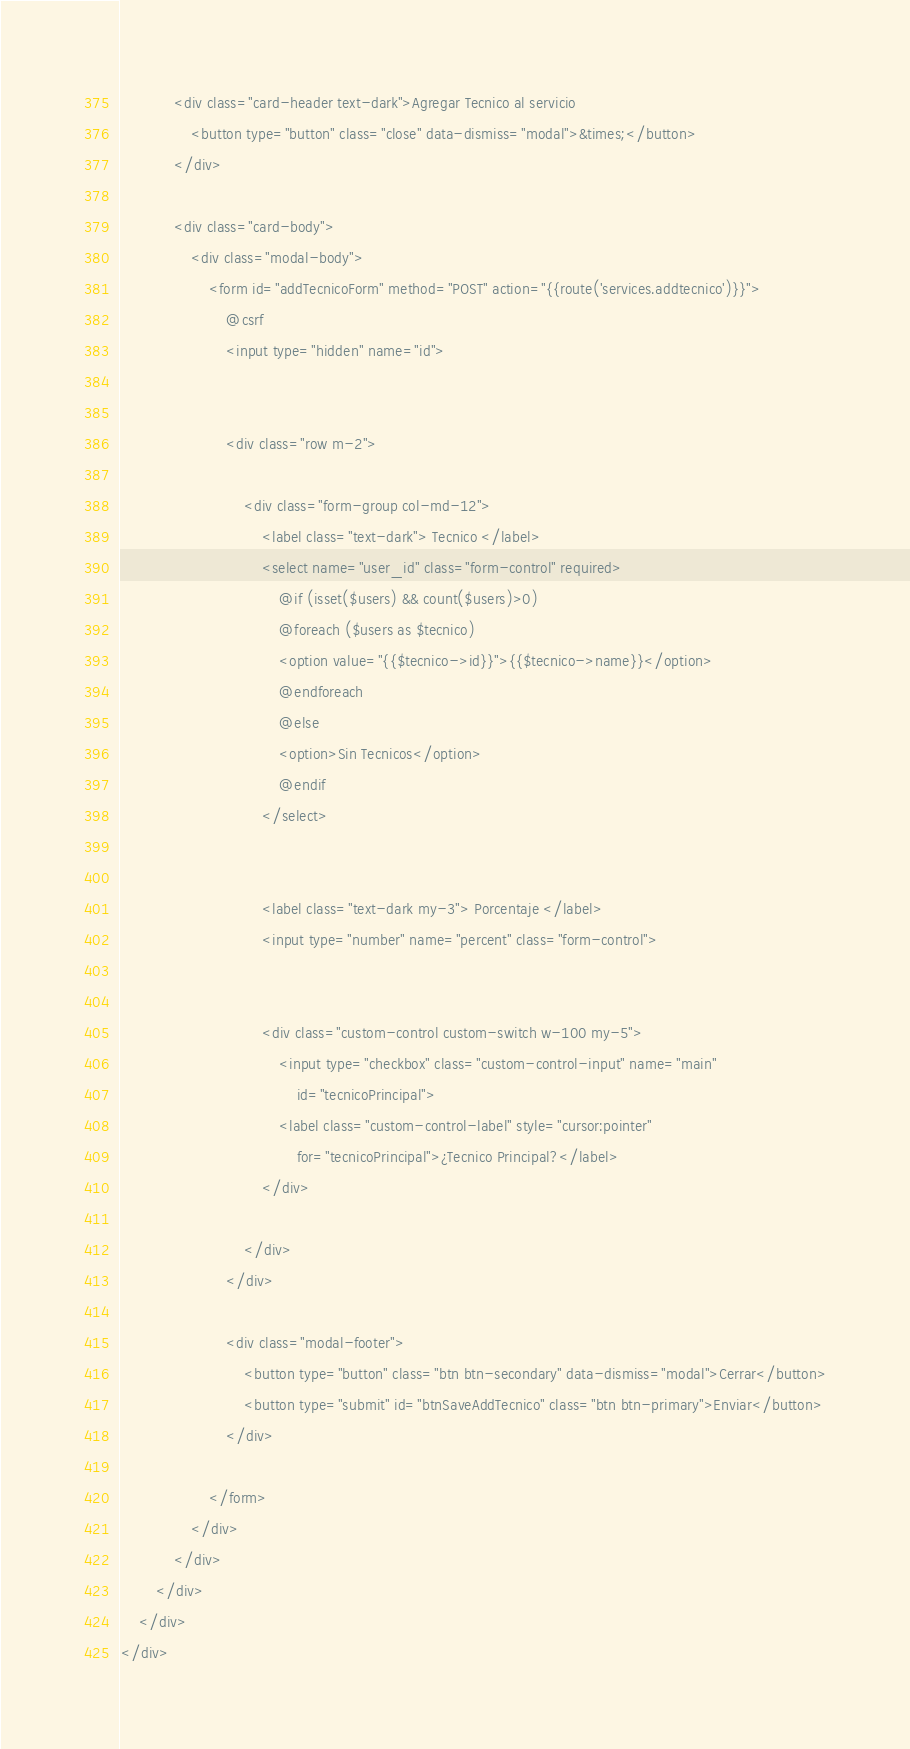Convert code to text. <code><loc_0><loc_0><loc_500><loc_500><_PHP_>
            <div class="card-header text-dark">Agregar Tecnico al servicio
                <button type="button" class="close" data-dismiss="modal">&times;</button>
            </div>

            <div class="card-body">
                <div class="modal-body">
                    <form id="addTecnicoForm" method="POST" action="{{route('services.addtecnico')}}">
                        @csrf
                        <input type="hidden" name="id">


                        <div class="row m-2">

                            <div class="form-group col-md-12">
                                <label class="text-dark"> Tecnico </label>
                                <select name="user_id" class="form-control" required>
                                    @if (isset($users) && count($users)>0)
                                    @foreach ($users as $tecnico)
                                    <option value="{{$tecnico->id}}">{{$tecnico->name}}</option>
                                    @endforeach
                                    @else
                                    <option>Sin Tecnicos</option>
                                    @endif
                                </select>


                                <label class="text-dark my-3"> Porcentaje </label>
                                <input type="number" name="percent" class="form-control">


                                <div class="custom-control custom-switch w-100 my-5">
                                    <input type="checkbox" class="custom-control-input" name="main"
                                        id="tecnicoPrincipal">
                                    <label class="custom-control-label" style="cursor:pointer"
                                        for="tecnicoPrincipal">¿Tecnico Principal?</label>
                                </div>

                            </div>
                        </div>

                        <div class="modal-footer">
                            <button type="button" class="btn btn-secondary" data-dismiss="modal">Cerrar</button>
                            <button type="submit" id="btnSaveAddTecnico" class="btn btn-primary">Enviar</button>
                        </div>

                    </form>
                </div>
            </div>
        </div>
    </div>
</div></code> 